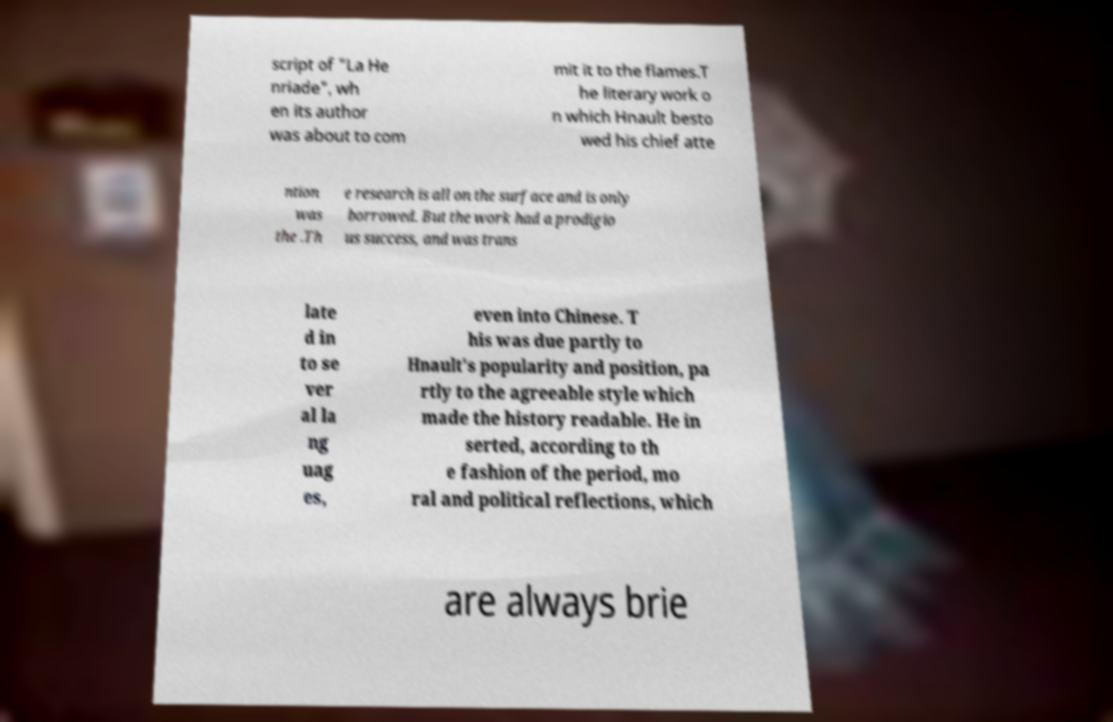Can you accurately transcribe the text from the provided image for me? script of "La He nriade", wh en its author was about to com mit it to the flames.T he literary work o n which Hnault besto wed his chief atte ntion was the .Th e research is all on the surface and is only borrowed. But the work had a prodigio us success, and was trans late d in to se ver al la ng uag es, even into Chinese. T his was due partly to Hnault's popularity and position, pa rtly to the agreeable style which made the history readable. He in serted, according to th e fashion of the period, mo ral and political reflections, which are always brie 